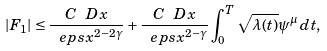<formula> <loc_0><loc_0><loc_500><loc_500>| F _ { 1 } | \leq \frac { C \ D x } { \ e p s x ^ { 2 - 2 \gamma } } + \frac { C \ D x } { \ e p s x ^ { 2 - \gamma } } \int _ { 0 } ^ { T } \sqrt { \lambda ( t ) } \psi ^ { \mu } \, d t ,</formula> 